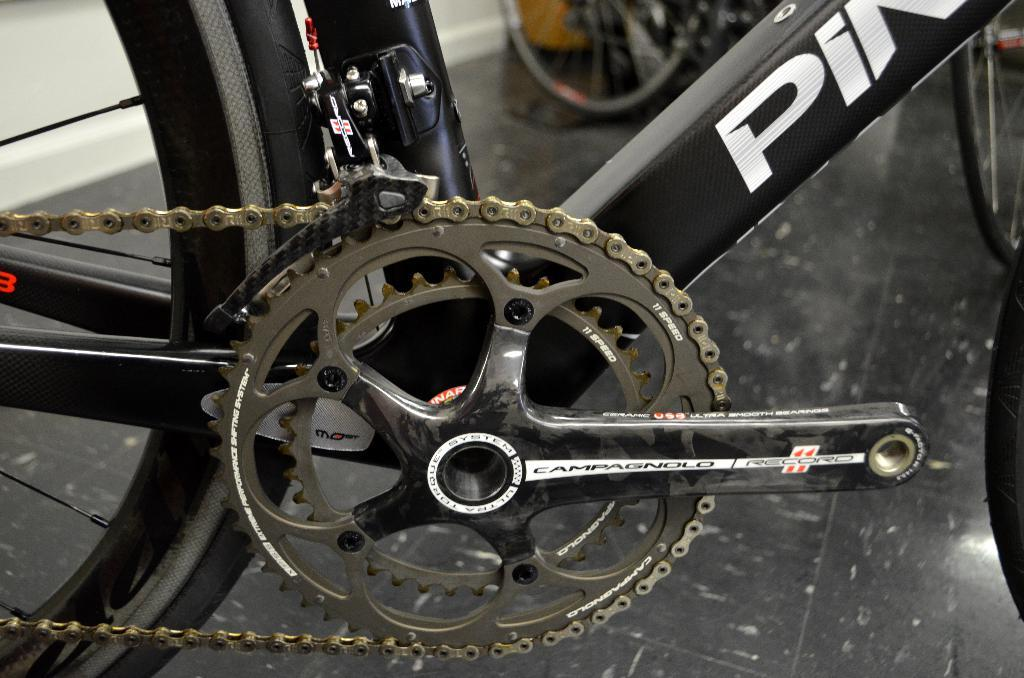What is the main subject in the foreground of the image? The main subject in the foreground of the image is the wheel and chain of a bicycle. What is the relationship between the wheel and chain in the image? The wheel and chain are part of a bicycle. What type of rubber component is visible in the image? There are tyres visible in the image. Can you describe the background of the image? In the background of the image, there is another bicycle on the floor. What is the background of the image made of? The wall is visible in the background of the image. What type of caption is written on the wall in the image? There is no caption visible on the wall in the image. Can you see a cat playing with the bicycle chain in the image? There is no cat present in the image. What type of cooking appliance is visible in the image? There is no oven present in the image. 